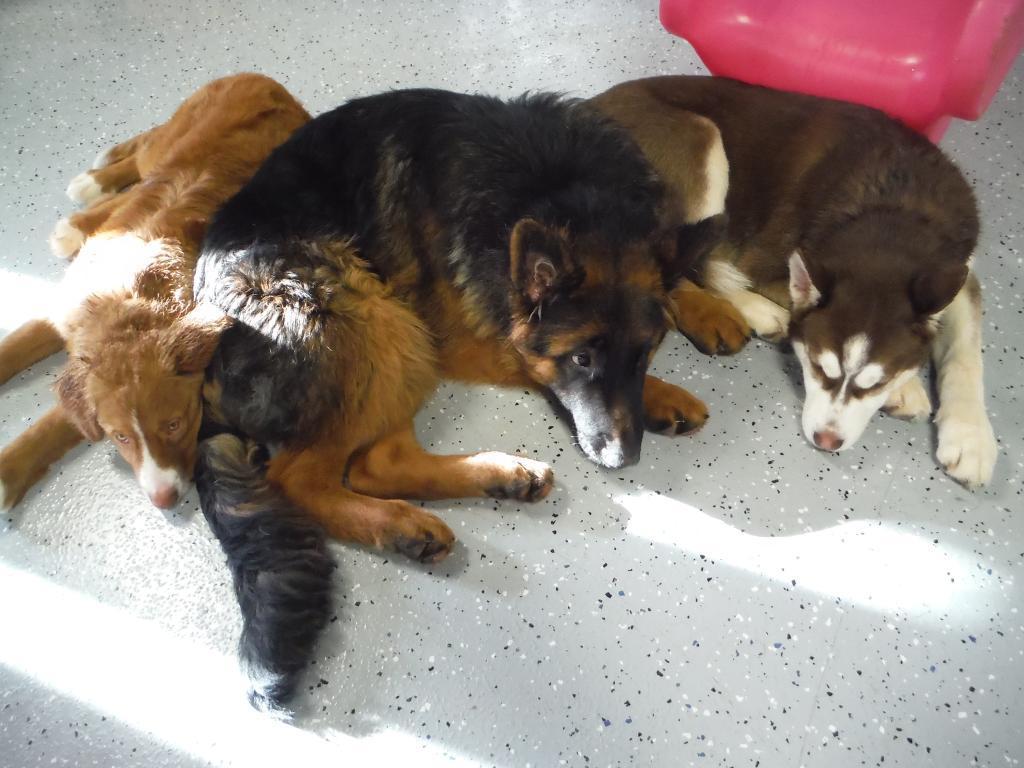Can you describe this image briefly? In this image we can see the three dogs on the floor. We can also see a red color object at the top. 